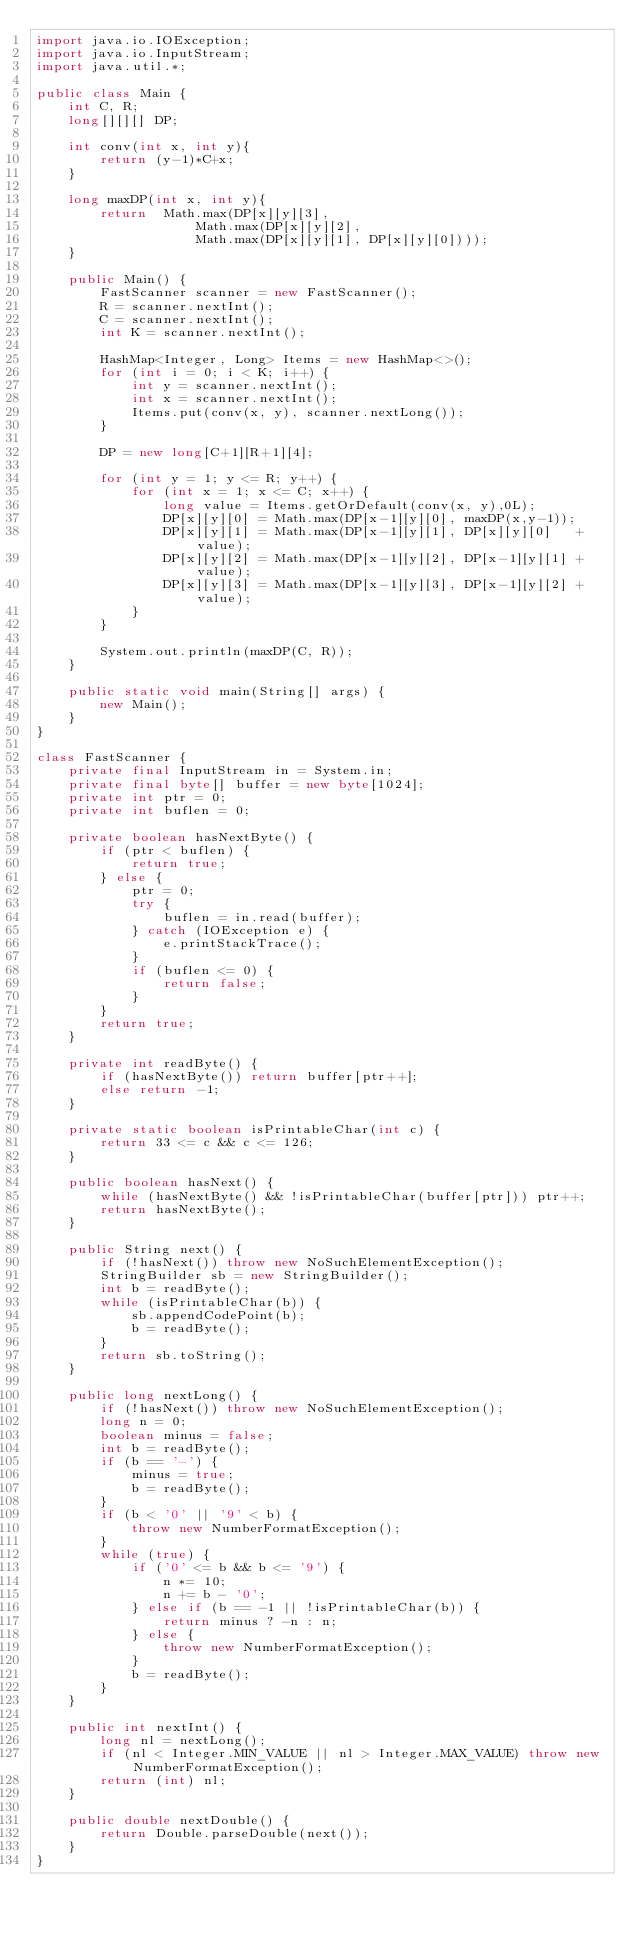<code> <loc_0><loc_0><loc_500><loc_500><_Java_>import java.io.IOException;
import java.io.InputStream;
import java.util.*;

public class Main {
	int C, R;
	long[][][] DP;
	
	int conv(int x, int y){
		return (y-1)*C+x;
	}
	
	long maxDP(int x, int y){
		return  Math.max(DP[x][y][3],
					Math.max(DP[x][y][2],
					Math.max(DP[x][y][1], DP[x][y][0])));
	}

	public Main() {
		FastScanner scanner = new FastScanner();
		R = scanner.nextInt();
		C = scanner.nextInt();
		int K = scanner.nextInt();

		HashMap<Integer, Long> Items = new HashMap<>();
		for (int i = 0; i < K; i++) {
			int y = scanner.nextInt();
			int x = scanner.nextInt();
			Items.put(conv(x, y), scanner.nextLong());
		}
		
		DP = new long[C+1][R+1][4];

		for (int y = 1; y <= R; y++) {
			for (int x = 1; x <= C; x++) {
				long value = Items.getOrDefault(conv(x, y),0L);
				DP[x][y][0] = Math.max(DP[x-1][y][0], maxDP(x,y-1));
				DP[x][y][1] = Math.max(DP[x-1][y][1], DP[x][y][0]   + value);
				DP[x][y][2] = Math.max(DP[x-1][y][2], DP[x-1][y][1] + value);
				DP[x][y][3] = Math.max(DP[x-1][y][3], DP[x-1][y][2] + value);
			}
		}

		System.out.println(maxDP(C, R));
	}

	public static void main(String[] args) {
		new Main();
	}
}

class FastScanner {
	private final InputStream in = System.in;
	private final byte[] buffer = new byte[1024];
	private int ptr = 0;
	private int buflen = 0;

	private boolean hasNextByte() {
		if (ptr < buflen) {
			return true;
		} else {
			ptr = 0;
			try {
				buflen = in.read(buffer);
			} catch (IOException e) {
				e.printStackTrace();
			}
			if (buflen <= 0) {
				return false;
			}
		}
		return true;
	}

	private int readByte() {
		if (hasNextByte()) return buffer[ptr++];
		else return -1;
	}

	private static boolean isPrintableChar(int c) {
		return 33 <= c && c <= 126;
	}

	public boolean hasNext() {
		while (hasNextByte() && !isPrintableChar(buffer[ptr])) ptr++;
		return hasNextByte();
	}

	public String next() {
		if (!hasNext()) throw new NoSuchElementException();
		StringBuilder sb = new StringBuilder();
		int b = readByte();
		while (isPrintableChar(b)) {
			sb.appendCodePoint(b);
			b = readByte();
		}
		return sb.toString();
	}

	public long nextLong() {
		if (!hasNext()) throw new NoSuchElementException();
		long n = 0;
		boolean minus = false;
		int b = readByte();
		if (b == '-') {
			minus = true;
			b = readByte();
		}
		if (b < '0' || '9' < b) {
			throw new NumberFormatException();
		}
		while (true) {
			if ('0' <= b && b <= '9') {
				n *= 10;
				n += b - '0';
			} else if (b == -1 || !isPrintableChar(b)) {
				return minus ? -n : n;
			} else {
				throw new NumberFormatException();
			}
			b = readByte();
		}
	}

	public int nextInt() {
		long nl = nextLong();
		if (nl < Integer.MIN_VALUE || nl > Integer.MAX_VALUE) throw new NumberFormatException();
		return (int) nl;
	}

	public double nextDouble() {
		return Double.parseDouble(next());
	}
}
</code> 